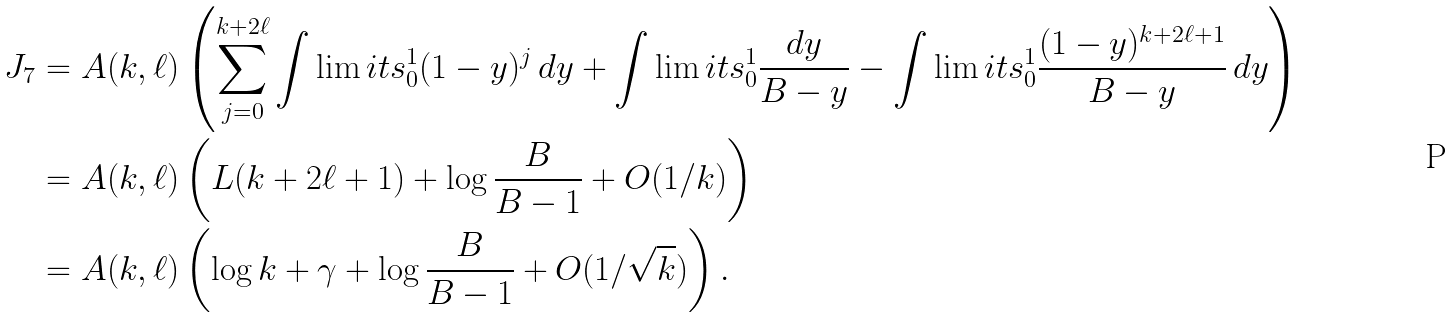Convert formula to latex. <formula><loc_0><loc_0><loc_500><loc_500>J _ { 7 } & = A ( k , \ell ) \left ( \sum ^ { k + 2 \ell } _ { j = 0 } \int \lim i t s ^ { 1 } _ { 0 } ( 1 - y ) ^ { j } \, d y + \int \lim i t s ^ { 1 } _ { 0 } \frac { d y } { B - y } - \int \lim i t s ^ { 1 } _ { 0 } \frac { ( 1 - y ) ^ { k + 2 \ell + 1 } } { B - y } \, d y \right ) \\ & = A ( k , \ell ) \left ( L ( k + 2 \ell + 1 ) + \log \frac { B } { B - 1 } + O ( 1 / k ) \right ) \\ & = A ( k , \ell ) \left ( \log k + \gamma + \log \frac { B } { B - 1 } + O ( 1 / \sqrt { k } ) \right ) .</formula> 